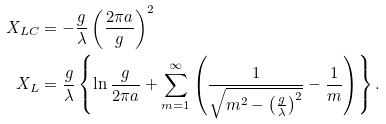<formula> <loc_0><loc_0><loc_500><loc_500>X _ { L C } & = - \frac { g } { \lambda } \left ( \frac { 2 \pi a } { g } \right ) ^ { 2 } \\ X _ { L } & = \frac { g } { \lambda } \left \{ \ln \frac { g } { 2 \pi a } + \sum _ { m = 1 } ^ { \infty } \left ( \frac { 1 } { \sqrt { m ^ { 2 } - \left ( \frac { g } { \lambda } \right ) ^ { 2 } } } - \frac { 1 } { m } \right ) \right \} .</formula> 